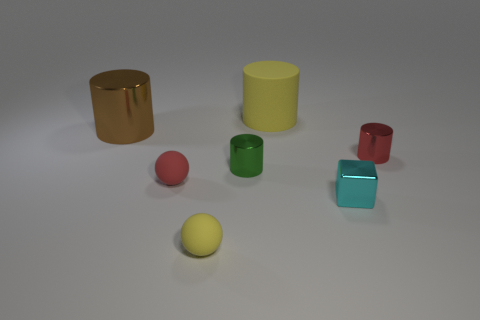Is there any other thing that is the same shape as the brown metallic thing?
Make the answer very short. Yes. Do the big matte cylinder and the metallic object that is behind the tiny red cylinder have the same color?
Make the answer very short. No. The yellow rubber thing that is to the left of the tiny green shiny cylinder has what shape?
Your answer should be very brief. Sphere. How many other objects are there of the same material as the big yellow thing?
Your response must be concise. 2. What is the material of the yellow ball?
Make the answer very short. Rubber. How many tiny objects are either red matte things or cyan metal objects?
Keep it short and to the point. 2. How many yellow rubber cylinders are left of the tiny yellow rubber sphere?
Your response must be concise. 0. Are there any tiny objects of the same color as the metal block?
Offer a terse response. No. What is the shape of the metallic thing that is the same size as the yellow cylinder?
Give a very brief answer. Cylinder. How many brown objects are either tiny shiny cubes or rubber cylinders?
Give a very brief answer. 0. 